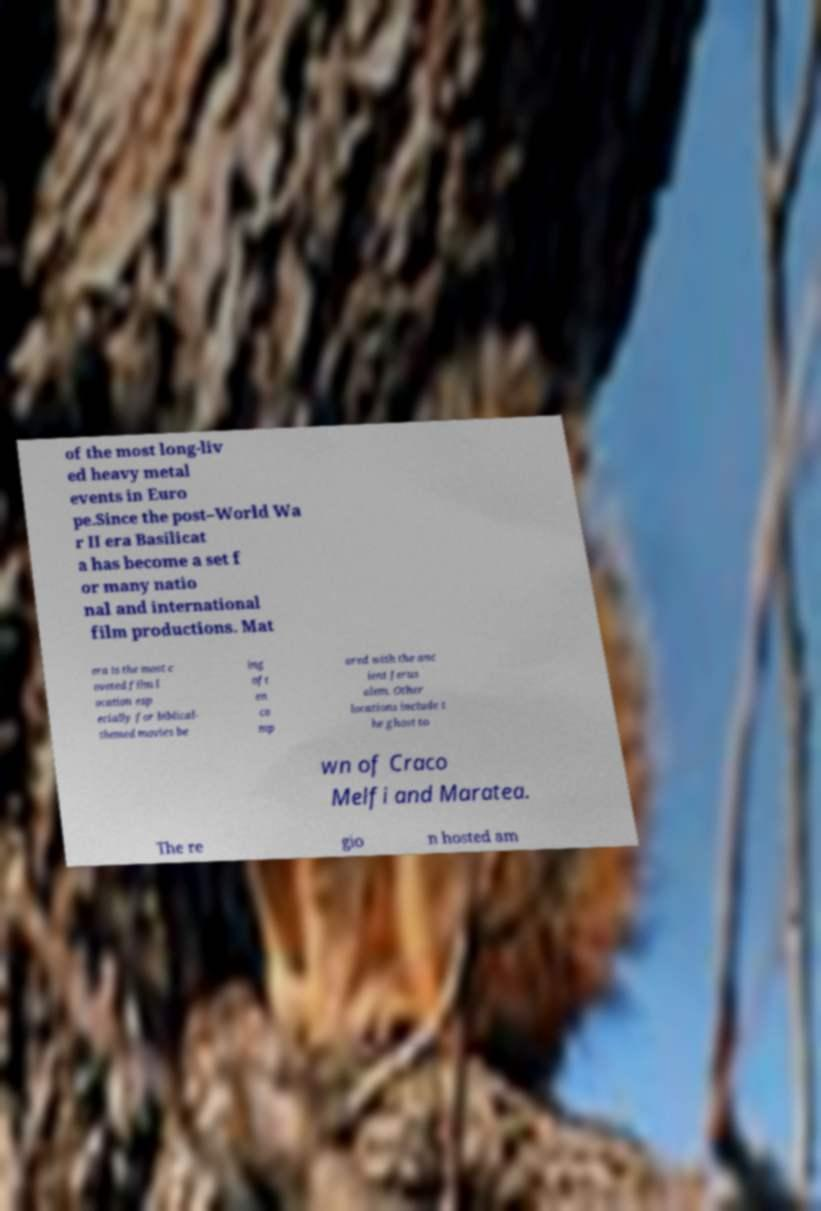There's text embedded in this image that I need extracted. Can you transcribe it verbatim? of the most long-liv ed heavy metal events in Euro pe.Since the post–World Wa r II era Basilicat a has become a set f or many natio nal and international film productions. Mat era is the most c oveted film l ocation esp ecially for biblical- themed movies be ing oft en co mp ared with the anc ient Jerus alem. Other locations include t he ghost to wn of Craco Melfi and Maratea. The re gio n hosted am 